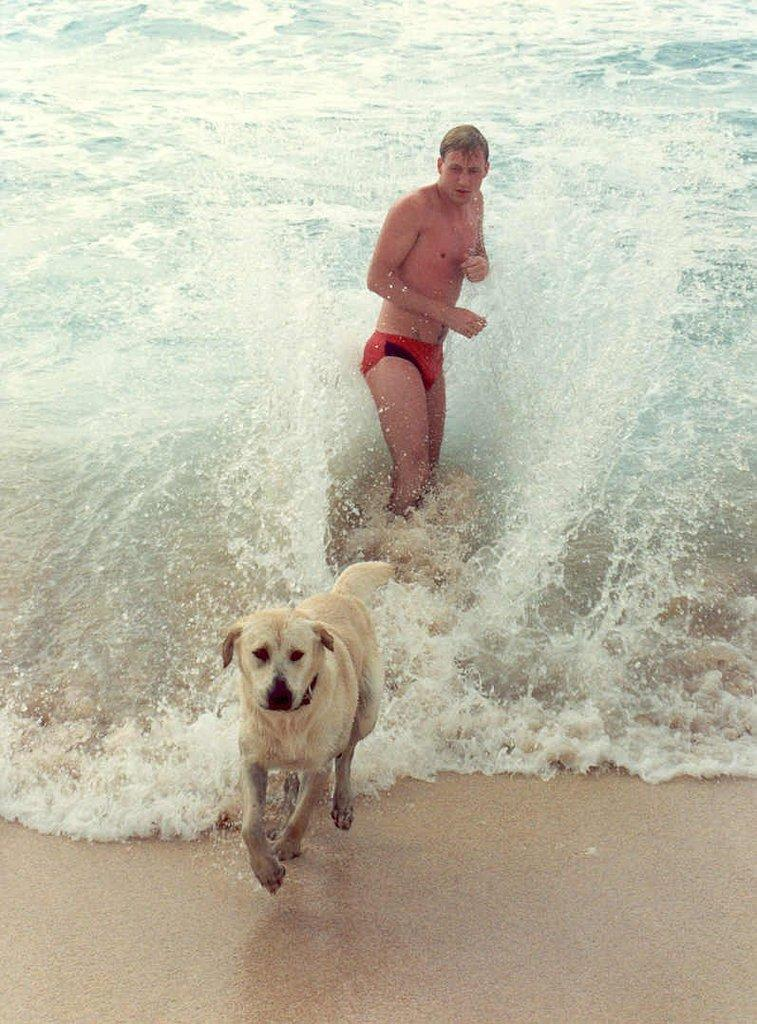What type of animal is in the image? There is a dog in the image. Can you describe the color of the dog? The dog is brown and cream in color. Who else is present in the image? There is a person in the image. What type of terrain is visible in the image? There is sand visible in the image. What can be seen in the background of the image? There is water visible in the background of the image. How does the dog range across the sand in the image? The dog is not shown actively moving or ranging across the sand in the image; it is stationary. 